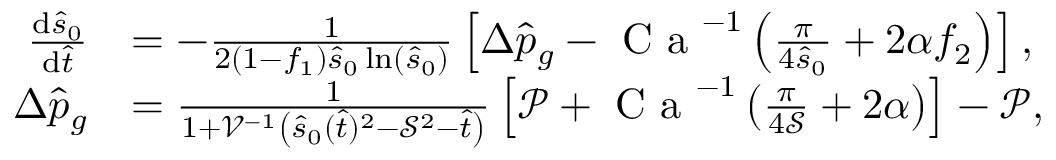<formula> <loc_0><loc_0><loc_500><loc_500>\begin{array} { r l } { \frac { d \hat { s } _ { 0 } } { d \hat { t } } } & { = - \frac { 1 } { 2 ( 1 - f _ { 1 } ) \hat { s } _ { 0 } \ln \left ( \hat { s } _ { 0 } \right ) } \left [ \Delta \hat { p } _ { g } - C a ^ { - 1 } \left ( \frac { \pi } { 4 \hat { s } _ { 0 } } + 2 \alpha f _ { 2 } \right ) \right ] , } \\ { \Delta \hat { p } _ { g } } & { = \frac { 1 } { 1 + \mathcal { V } ^ { - 1 } \left ( \hat { s } _ { 0 } ( \hat { t } ) ^ { 2 } - \mathcal { S } ^ { 2 } - \hat { t } \right ) } \left [ \mathcal { P } + C a ^ { - 1 } \left ( \frac { \pi } { 4 \mathcal { S } } + 2 \alpha \right ) \right ] - \mathcal { P } , } \end{array}</formula> 